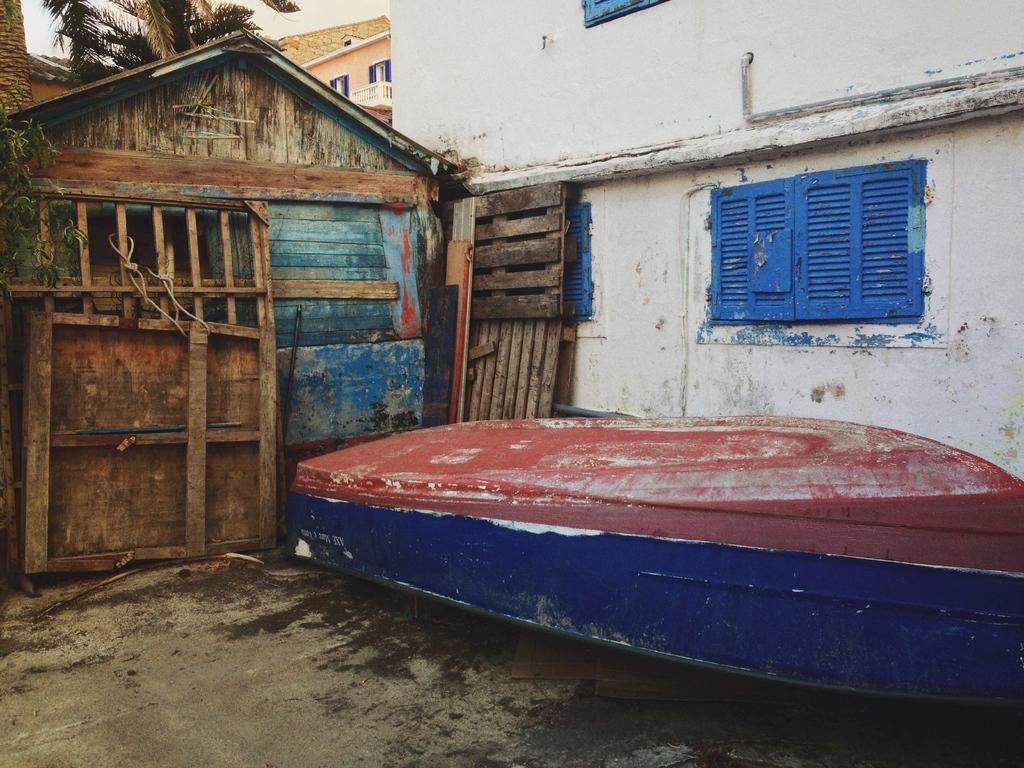What type of structures are visible in the image? There are houses in the image. What natural element can be seen in the image? There is a tree in the image. What mode of transportation is present in the image? There is a boat in the image. What surface is depicted at the bottom of the image? The bottom of the image appears to represent a floor. What type of jewel is hanging from the tree in the image? There is no jewel hanging from the tree in the image; it only features a tree and other elements mentioned in the facts. How many visitors can be seen interacting with the boat in the image? There is no visitor present in the image; it only features a boat and other elements mentioned in the facts. 